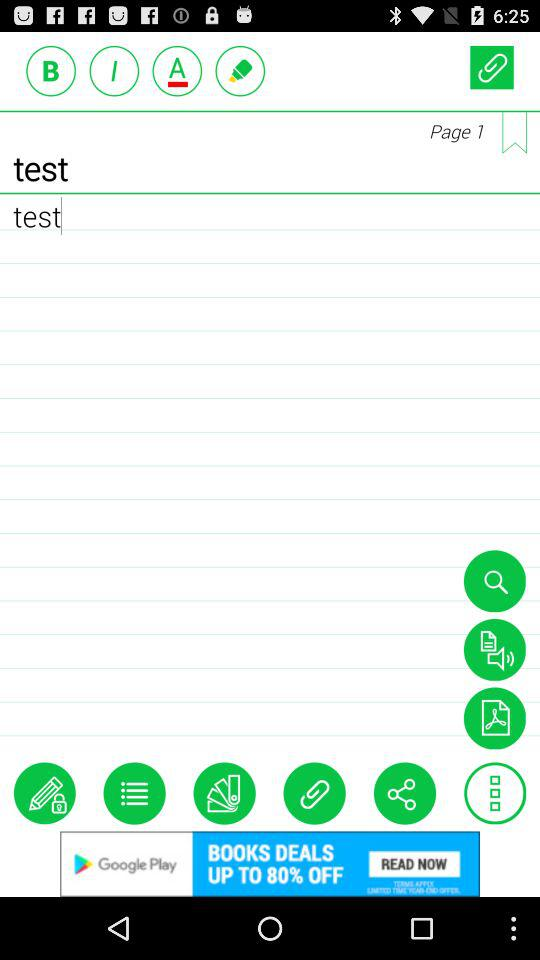What is the page number? The page number is 1. 